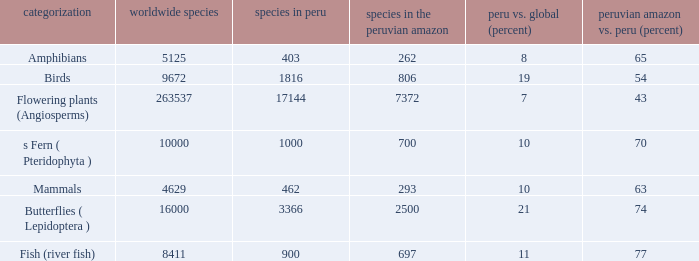What's the minimum species in the peruvian amazon with species in peru of 1000 700.0. 